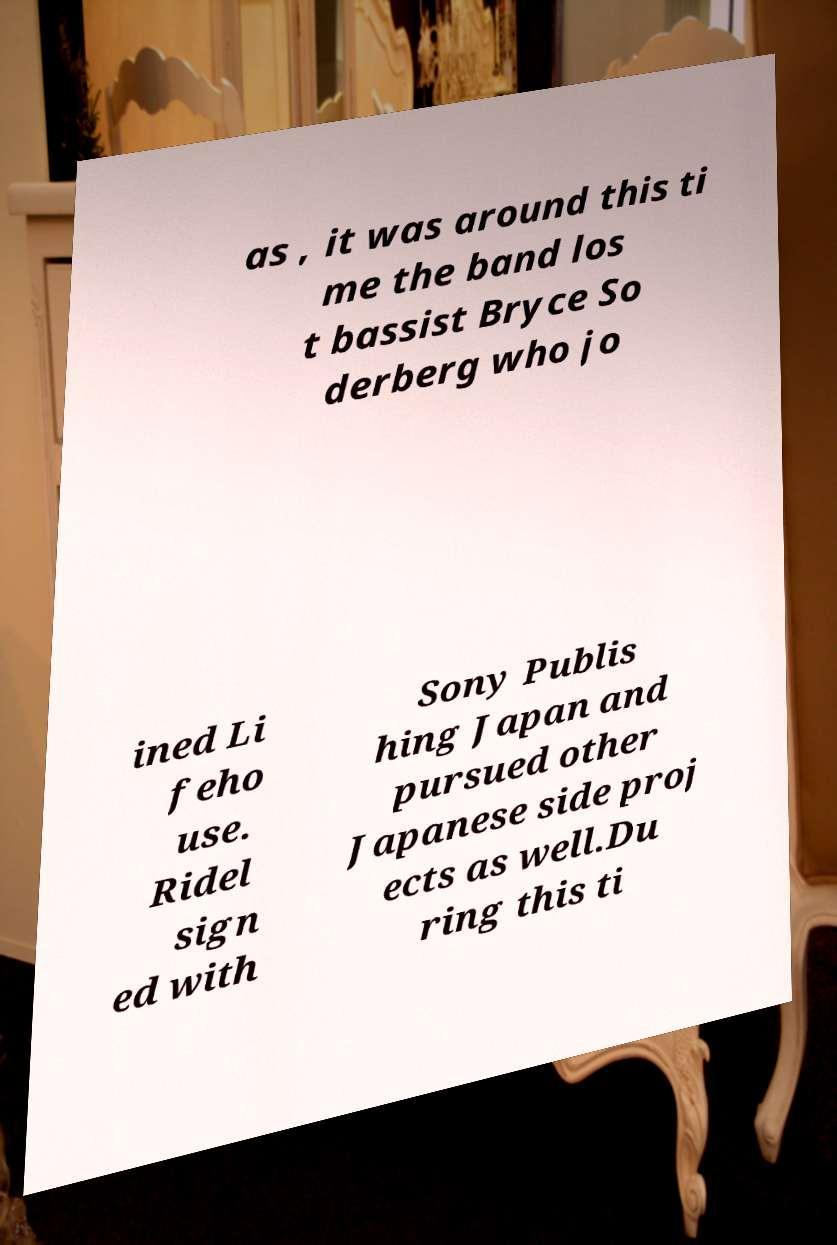Can you read and provide the text displayed in the image?This photo seems to have some interesting text. Can you extract and type it out for me? as , it was around this ti me the band los t bassist Bryce So derberg who jo ined Li feho use. Ridel sign ed with Sony Publis hing Japan and pursued other Japanese side proj ects as well.Du ring this ti 